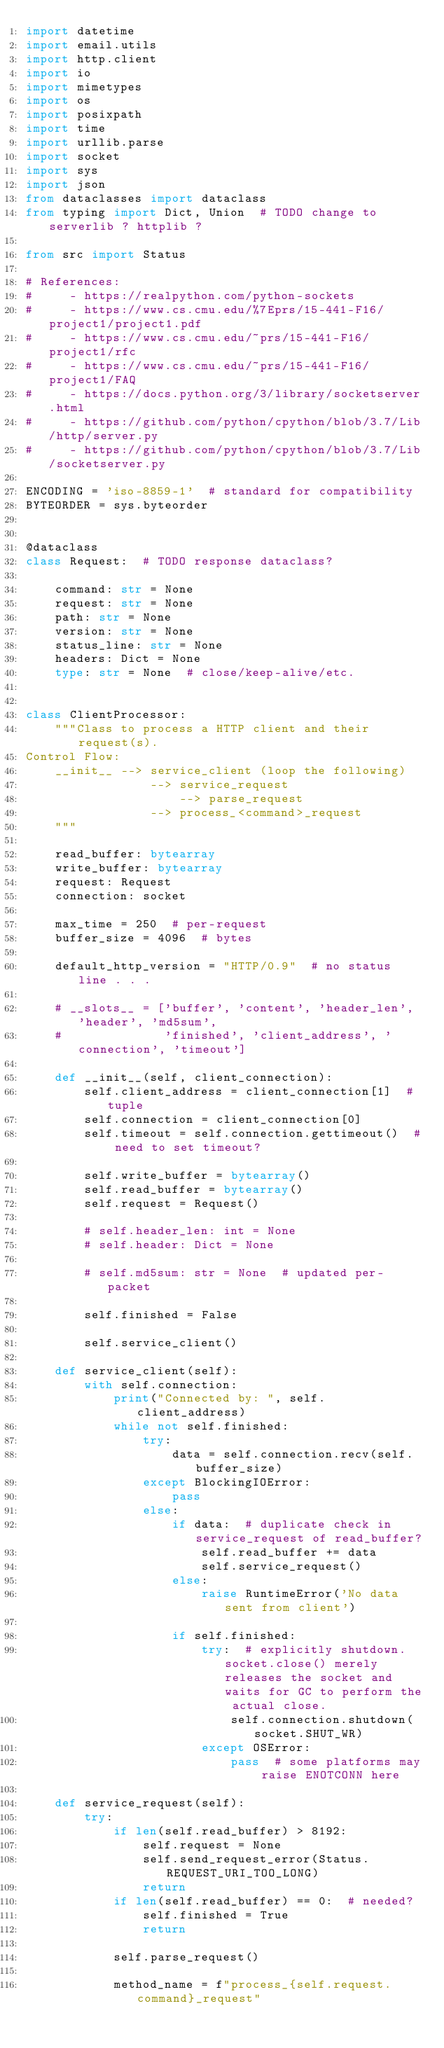<code> <loc_0><loc_0><loc_500><loc_500><_Python_>import datetime
import email.utils
import http.client
import io
import mimetypes
import os
import posixpath
import time
import urllib.parse
import socket
import sys
import json
from dataclasses import dataclass
from typing import Dict, Union  # TODO change to serverlib ? httplib ?

from src import Status

# References:
#     - https://realpython.com/python-sockets
#     - https://www.cs.cmu.edu/%7Eprs/15-441-F16/project1/project1.pdf
#     - https://www.cs.cmu.edu/~prs/15-441-F16/project1/rfc
#     - https://www.cs.cmu.edu/~prs/15-441-F16/project1/FAQ
#     - https://docs.python.org/3/library/socketserver.html
#     - https://github.com/python/cpython/blob/3.7/Lib/http/server.py
#     - https://github.com/python/cpython/blob/3.7/Lib/socketserver.py

ENCODING = 'iso-8859-1'  # standard for compatibility
BYTEORDER = sys.byteorder


@dataclass
class Request:  # TODO response dataclass?

    command: str = None
    request: str = None
    path: str = None
    version: str = None
    status_line: str = None
    headers: Dict = None
    type: str = None  # close/keep-alive/etc.


class ClientProcessor:
    """Class to process a HTTP client and their request(s).
Control Flow:
    __init__ --> service_client (loop the following)
                 --> service_request
                     --> parse_request
                 --> process_<command>_request
    """

    read_buffer: bytearray
    write_buffer: bytearray
    request: Request
    connection: socket

    max_time = 250  # per-request
    buffer_size = 4096  # bytes

    default_http_version = "HTTP/0.9"  # no status line . . .

    # __slots__ = ['buffer', 'content', 'header_len', 'header', 'md5sum',
    #              'finished', 'client_address', 'connection', 'timeout']

    def __init__(self, client_connection):
        self.client_address = client_connection[1]  # tuple
        self.connection = client_connection[0]
        self.timeout = self.connection.gettimeout()  # need to set timeout?

        self.write_buffer = bytearray()
        self.read_buffer = bytearray()
        self.request = Request()

        # self.header_len: int = None
        # self.header: Dict = None

        # self.md5sum: str = None  # updated per-packet

        self.finished = False

        self.service_client()

    def service_client(self):
        with self.connection:
            print("Connected by: ", self.client_address)
            while not self.finished:
                try:
                    data = self.connection.recv(self.buffer_size)
                except BlockingIOError:
                    pass
                else:
                    if data:  # duplicate check in service_request of read_buffer?
                        self.read_buffer += data
                        self.service_request()
                    else:
                        raise RuntimeError('No data sent from client')

                    if self.finished:
                        try:  # explicitly shutdown.  socket.close() merely releases the socket and waits for GC to perform the actual close.
                            self.connection.shutdown(socket.SHUT_WR)
                        except OSError:
                            pass  # some platforms may raise ENOTCONN here

    def service_request(self):
        try:
            if len(self.read_buffer) > 8192:
                self.request = None
                self.send_request_error(Status.REQUEST_URI_TOO_LONG)
                return
            if len(self.read_buffer) == 0:  # needed?
                self.finished = True
                return

            self.parse_request()

            method_name = f"process_{self.request.command}_request"</code> 